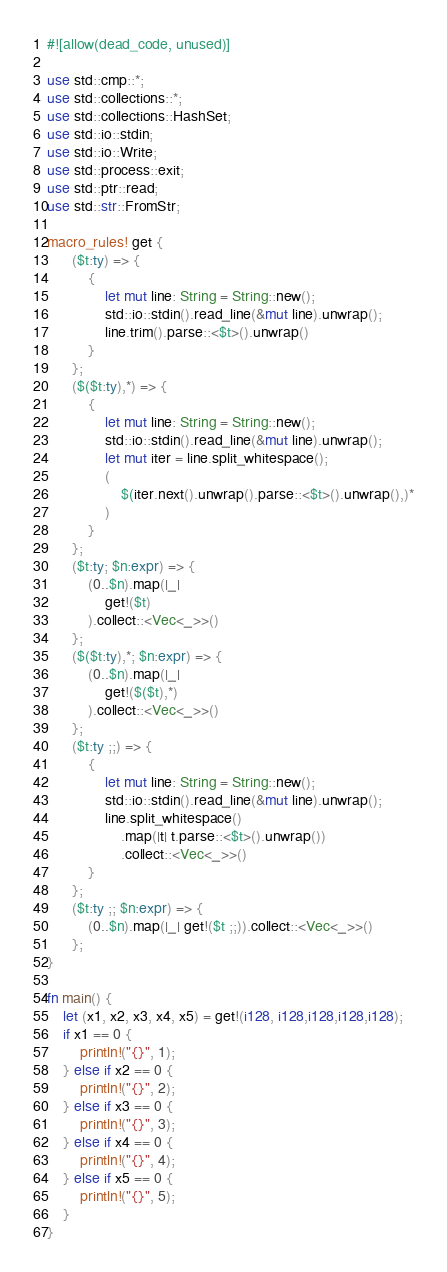<code> <loc_0><loc_0><loc_500><loc_500><_Rust_>#![allow(dead_code, unused)]

use std::cmp::*;
use std::collections::*;
use std::collections::HashSet;
use std::io::stdin;
use std::io::Write;
use std::process::exit;
use std::ptr::read;
use std::str::FromStr;

macro_rules! get {
      ($t:ty) => {
          {
              let mut line: String = String::new();
              std::io::stdin().read_line(&mut line).unwrap();
              line.trim().parse::<$t>().unwrap()
          }
      };
      ($($t:ty),*) => {
          {
              let mut line: String = String::new();
              std::io::stdin().read_line(&mut line).unwrap();
              let mut iter = line.split_whitespace();
              (
                  $(iter.next().unwrap().parse::<$t>().unwrap(),)*
              )
          }
      };
      ($t:ty; $n:expr) => {
          (0..$n).map(|_|
              get!($t)
          ).collect::<Vec<_>>()
      };
      ($($t:ty),*; $n:expr) => {
          (0..$n).map(|_|
              get!($($t),*)
          ).collect::<Vec<_>>()
      };
      ($t:ty ;;) => {
          {
              let mut line: String = String::new();
              std::io::stdin().read_line(&mut line).unwrap();
              line.split_whitespace()
                  .map(|t| t.parse::<$t>().unwrap())
                  .collect::<Vec<_>>()
          }
      };
      ($t:ty ;; $n:expr) => {
          (0..$n).map(|_| get!($t ;;)).collect::<Vec<_>>()
      };
}

fn main() {
    let (x1, x2, x3, x4, x5) = get!(i128, i128,i128,i128,i128);
    if x1 == 0 {
        println!("{}", 1);
    } else if x2 == 0 {
        println!("{}", 2);
    } else if x3 == 0 {
        println!("{}", 3);
    } else if x4 == 0 {
        println!("{}", 4);
    } else if x5 == 0 {
        println!("{}", 5);
    }
}</code> 